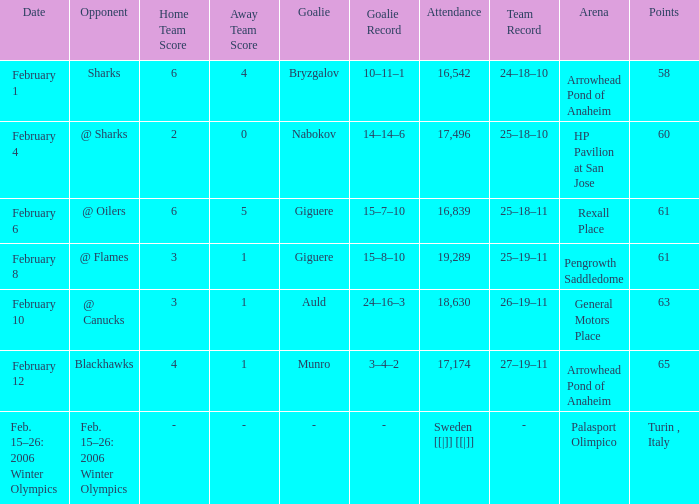When the game had a 3-1 score, what were the points for the recorded 25-19-11? 61.0. 